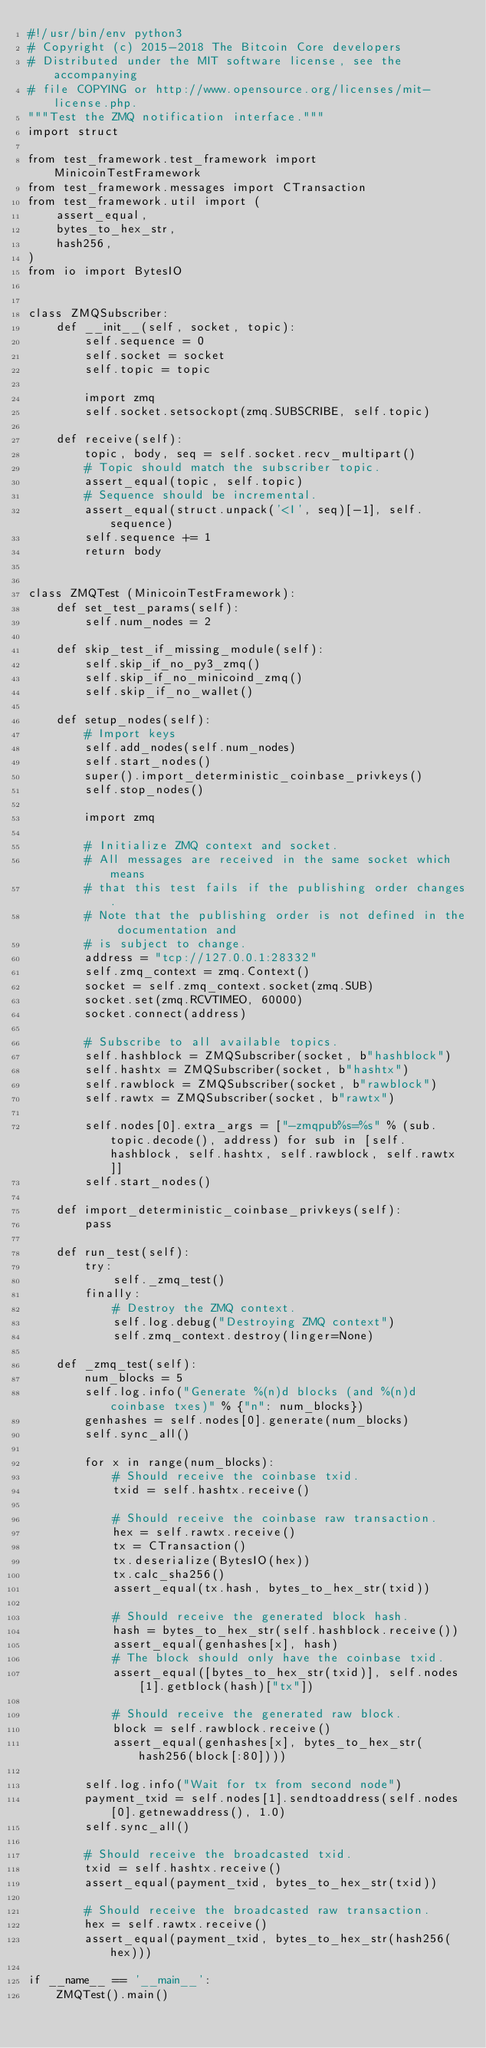Convert code to text. <code><loc_0><loc_0><loc_500><loc_500><_Python_>#!/usr/bin/env python3
# Copyright (c) 2015-2018 The Bitcoin Core developers
# Distributed under the MIT software license, see the accompanying
# file COPYING or http://www.opensource.org/licenses/mit-license.php.
"""Test the ZMQ notification interface."""
import struct

from test_framework.test_framework import MinicoinTestFramework
from test_framework.messages import CTransaction
from test_framework.util import (
    assert_equal,
    bytes_to_hex_str,
    hash256,
)
from io import BytesIO


class ZMQSubscriber:
    def __init__(self, socket, topic):
        self.sequence = 0
        self.socket = socket
        self.topic = topic

        import zmq
        self.socket.setsockopt(zmq.SUBSCRIBE, self.topic)

    def receive(self):
        topic, body, seq = self.socket.recv_multipart()
        # Topic should match the subscriber topic.
        assert_equal(topic, self.topic)
        # Sequence should be incremental.
        assert_equal(struct.unpack('<I', seq)[-1], self.sequence)
        self.sequence += 1
        return body


class ZMQTest (MinicoinTestFramework):
    def set_test_params(self):
        self.num_nodes = 2

    def skip_test_if_missing_module(self):
        self.skip_if_no_py3_zmq()
        self.skip_if_no_minicoind_zmq()
        self.skip_if_no_wallet()

    def setup_nodes(self):
        # Import keys
        self.add_nodes(self.num_nodes)
        self.start_nodes()
        super().import_deterministic_coinbase_privkeys()
        self.stop_nodes()

        import zmq

        # Initialize ZMQ context and socket.
        # All messages are received in the same socket which means
        # that this test fails if the publishing order changes.
        # Note that the publishing order is not defined in the documentation and
        # is subject to change.
        address = "tcp://127.0.0.1:28332"
        self.zmq_context = zmq.Context()
        socket = self.zmq_context.socket(zmq.SUB)
        socket.set(zmq.RCVTIMEO, 60000)
        socket.connect(address)

        # Subscribe to all available topics.
        self.hashblock = ZMQSubscriber(socket, b"hashblock")
        self.hashtx = ZMQSubscriber(socket, b"hashtx")
        self.rawblock = ZMQSubscriber(socket, b"rawblock")
        self.rawtx = ZMQSubscriber(socket, b"rawtx")

        self.nodes[0].extra_args = ["-zmqpub%s=%s" % (sub.topic.decode(), address) for sub in [self.hashblock, self.hashtx, self.rawblock, self.rawtx]]
        self.start_nodes()

    def import_deterministic_coinbase_privkeys(self):
        pass

    def run_test(self):
        try:
            self._zmq_test()
        finally:
            # Destroy the ZMQ context.
            self.log.debug("Destroying ZMQ context")
            self.zmq_context.destroy(linger=None)

    def _zmq_test(self):
        num_blocks = 5
        self.log.info("Generate %(n)d blocks (and %(n)d coinbase txes)" % {"n": num_blocks})
        genhashes = self.nodes[0].generate(num_blocks)
        self.sync_all()

        for x in range(num_blocks):
            # Should receive the coinbase txid.
            txid = self.hashtx.receive()

            # Should receive the coinbase raw transaction.
            hex = self.rawtx.receive()
            tx = CTransaction()
            tx.deserialize(BytesIO(hex))
            tx.calc_sha256()
            assert_equal(tx.hash, bytes_to_hex_str(txid))

            # Should receive the generated block hash.
            hash = bytes_to_hex_str(self.hashblock.receive())
            assert_equal(genhashes[x], hash)
            # The block should only have the coinbase txid.
            assert_equal([bytes_to_hex_str(txid)], self.nodes[1].getblock(hash)["tx"])

            # Should receive the generated raw block.
            block = self.rawblock.receive()
            assert_equal(genhashes[x], bytes_to_hex_str(hash256(block[:80])))

        self.log.info("Wait for tx from second node")
        payment_txid = self.nodes[1].sendtoaddress(self.nodes[0].getnewaddress(), 1.0)
        self.sync_all()

        # Should receive the broadcasted txid.
        txid = self.hashtx.receive()
        assert_equal(payment_txid, bytes_to_hex_str(txid))

        # Should receive the broadcasted raw transaction.
        hex = self.rawtx.receive()
        assert_equal(payment_txid, bytes_to_hex_str(hash256(hex)))

if __name__ == '__main__':
    ZMQTest().main()
</code> 